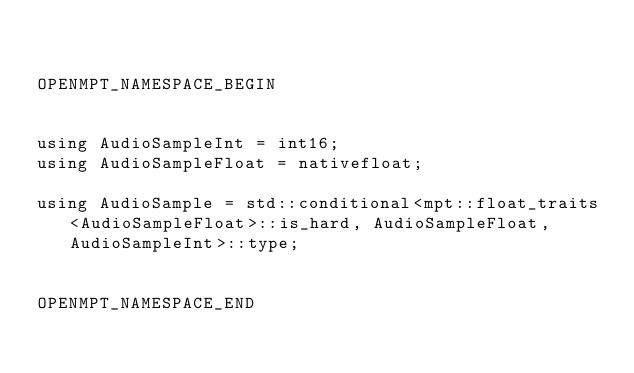<code> <loc_0><loc_0><loc_500><loc_500><_C_>

OPENMPT_NAMESPACE_BEGIN


using AudioSampleInt = int16;
using AudioSampleFloat = nativefloat;

using AudioSample = std::conditional<mpt::float_traits<AudioSampleFloat>::is_hard, AudioSampleFloat, AudioSampleInt>::type;


OPENMPT_NAMESPACE_END
</code> 